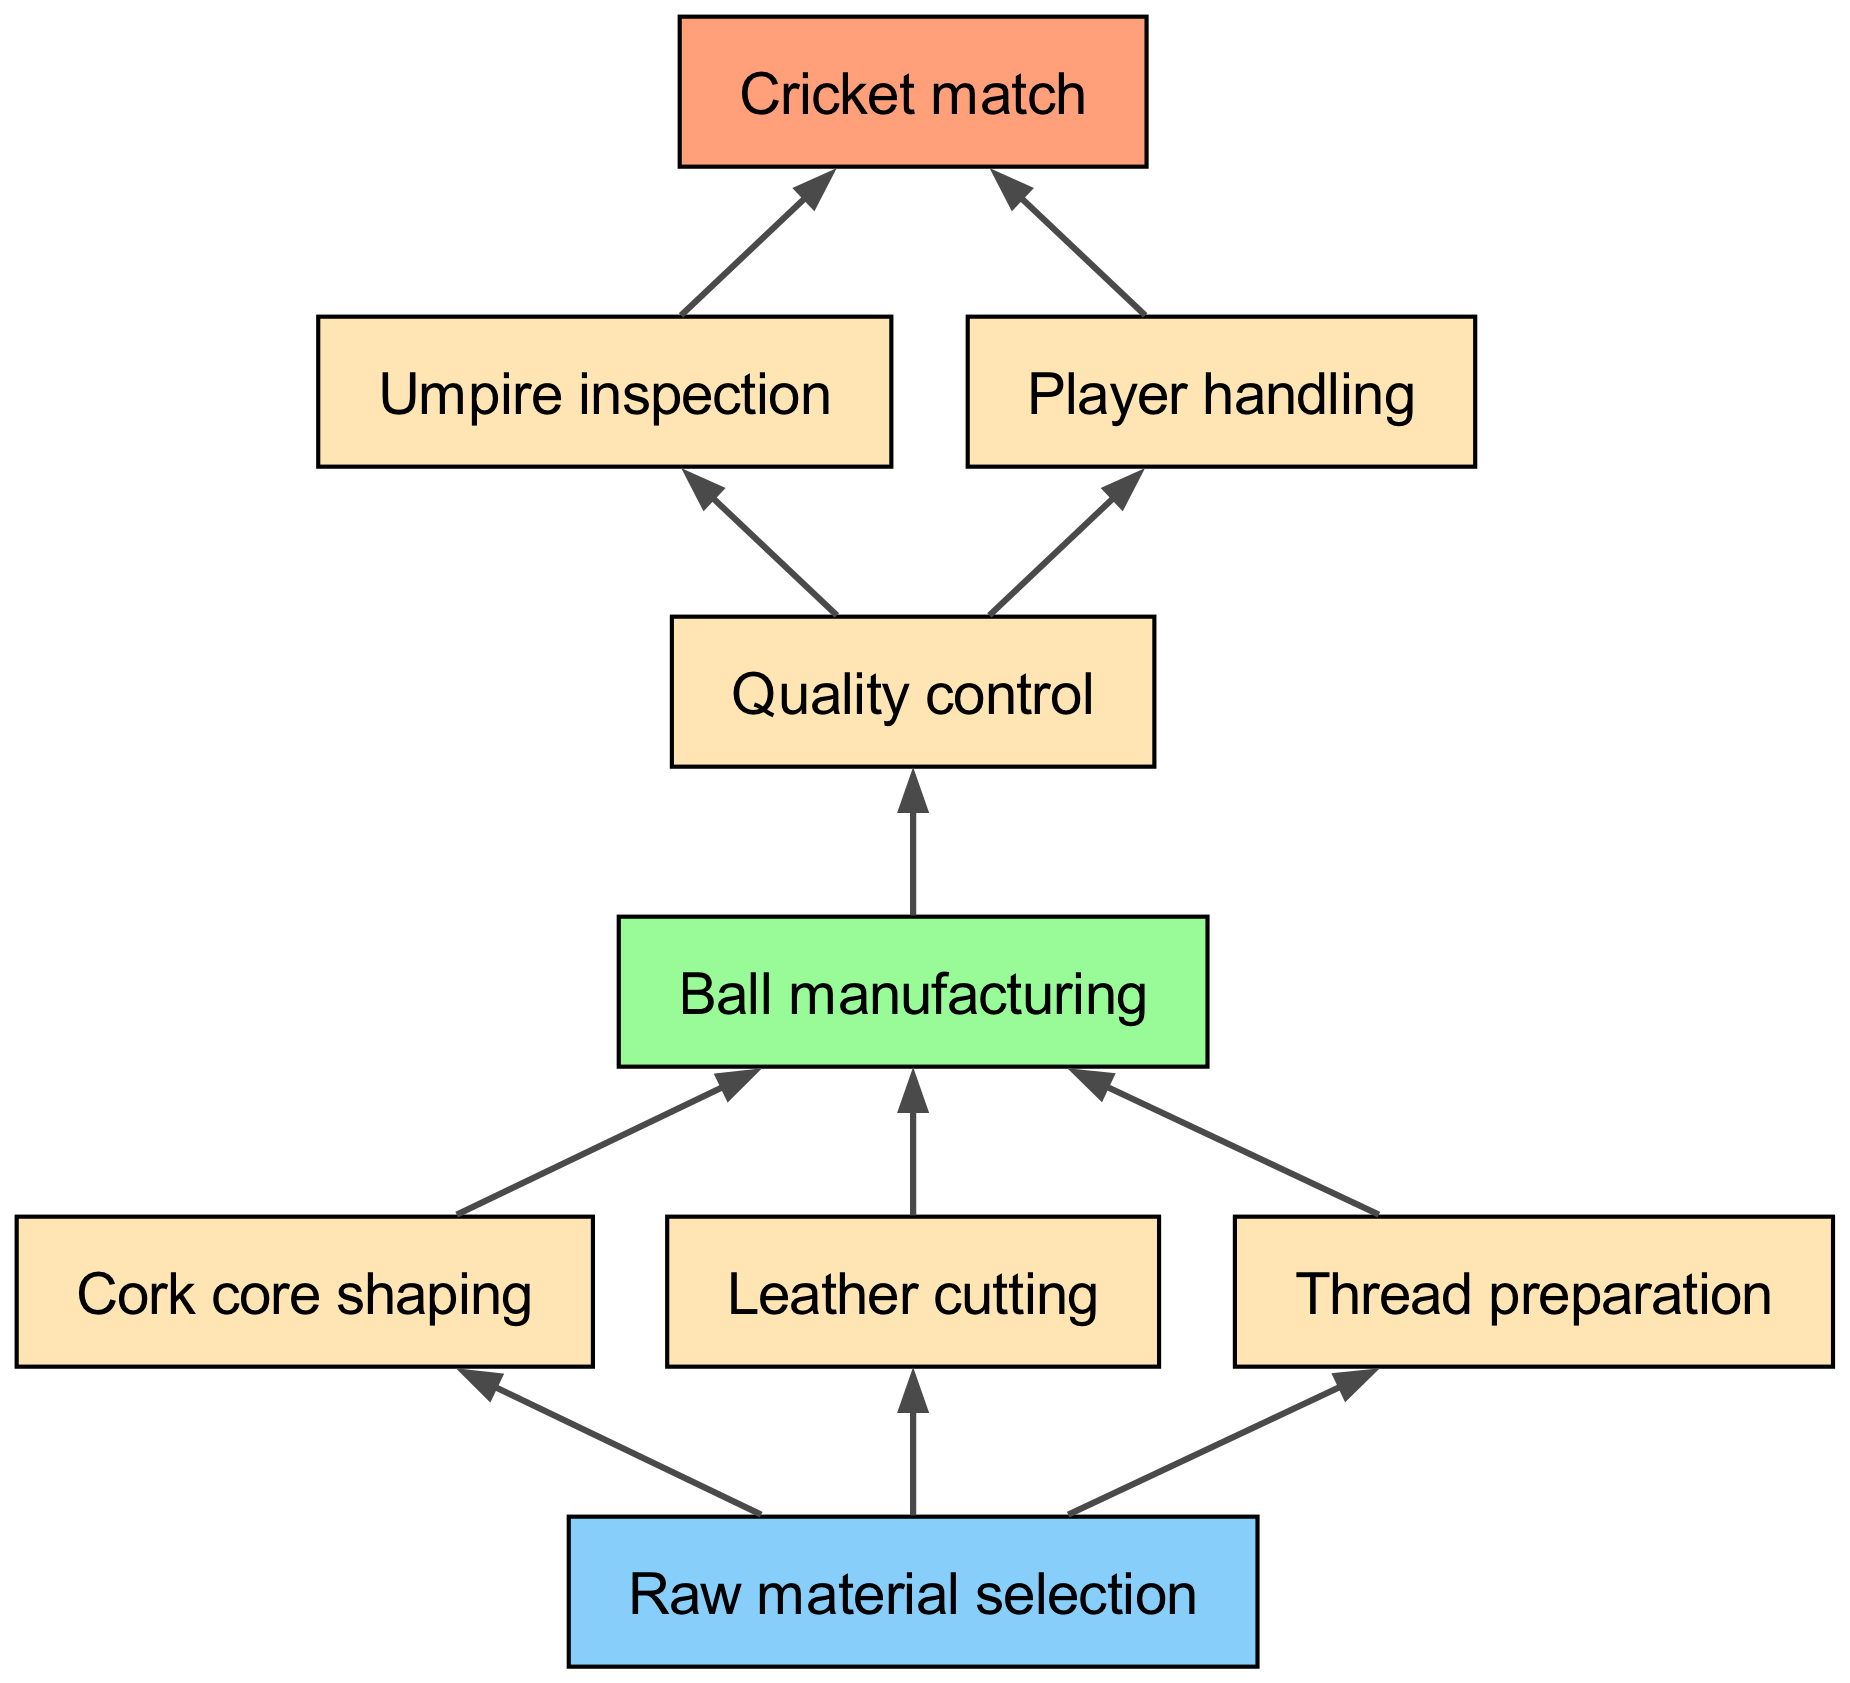What is the final step before the cricket match? The final step before the cricket match in the flow is the "Umpire inspection," which is directly connected to the "Cricket match" node.
Answer: Umpire inspection How many connections does the "Ball manufacturing" node have? The "Ball manufacturing" node has three connections: "Cork core shaping," "Leather cutting," and "Thread preparation." These are the nodes that lead into "Ball manufacturing."
Answer: 3 What is the second node in the flow before the "Quality control"? The second node before "Quality control" is "Ball manufacturing," as it directly connects to "Quality control."
Answer: Ball manufacturing Which step comes after "Player handling"? The step that comes after "Player handling" is "Quality control," as both "Umpire inspection" and "Player handling" connect to "Quality control."
Answer: Quality control What are the three processes involved in "Ball manufacturing"? The three processes involved in "Ball manufacturing" are "Cork core shaping," "Leather cutting," and "Thread preparation." These are the components that make up the manufacturing stage.
Answer: Cork core shaping, Leather cutting, Thread preparation How many total nodes are present in the diagram? The diagram contains a total of nine nodes, as listed in the data provided. These represent different stages in the journey of a cricket ball.
Answer: 9 What is the primary node from which all processes originate? The primary node from which all processes originate is "Raw material selection," as it is the foundation for the various manufacturing steps.
Answer: Raw material selection Which node is directly connected to both "Umpire inspection" and "Player handling"? The node directly connected to both "Umpire inspection" and "Player handling" is "Quality control," as it receives connections from both.
Answer: Quality control How does the diagram show the flow towards the cricket match? The diagram shows the flow towards the cricket match by connecting "Umpire inspection" and "Player handling" to "Quality control," which ultimately leads to "Cricket match." This indicates that these processes are essential before the match can begin.
Answer: By connecting "Umpire inspection" and "Player handling" to "Quality control" before "Cricket match." 